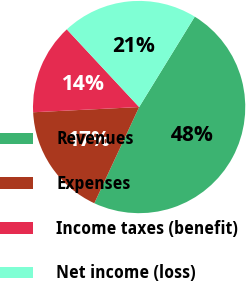Convert chart. <chart><loc_0><loc_0><loc_500><loc_500><pie_chart><fcel>Revenues<fcel>Expenses<fcel>Income taxes (benefit)<fcel>Net income (loss)<nl><fcel>48.16%<fcel>17.28%<fcel>13.85%<fcel>20.71%<nl></chart> 